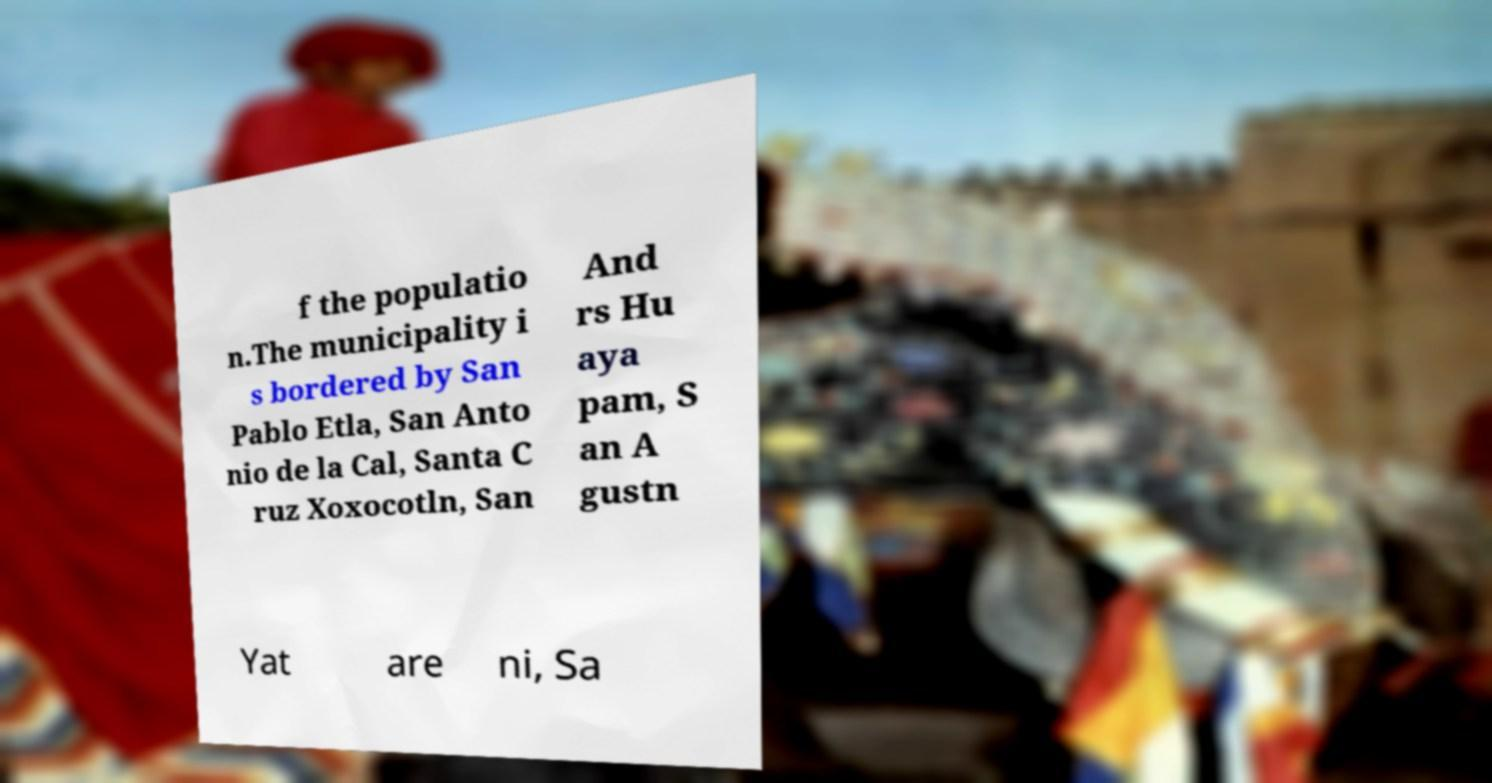What messages or text are displayed in this image? I need them in a readable, typed format. f the populatio n.The municipality i s bordered by San Pablo Etla, San Anto nio de la Cal, Santa C ruz Xoxocotln, San And rs Hu aya pam, S an A gustn Yat are ni, Sa 